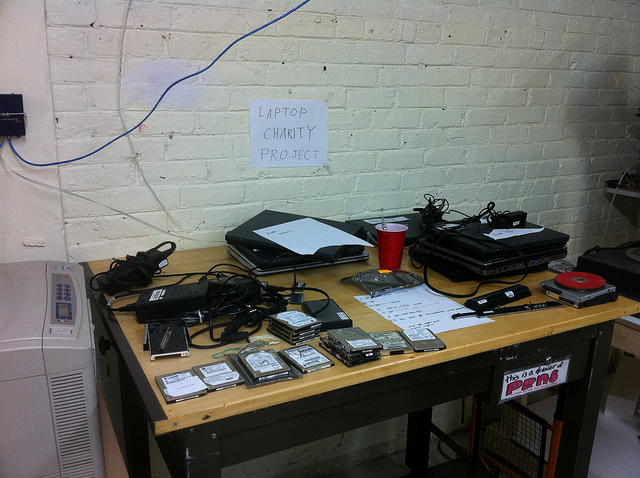<image>What logo is on the cup? I don't know what logo is on the cup. It can be 'solo' or none. What kind of pictures are shown? I am not sure what kind of pictures are shown. It could be cell phones, compact disks or computers. What logo is on the cup? I don't know what logo is on the cup. It can be either 'solo' or 'no logo'. What kind of pictures are shown? I don't know what kind of pictures are shown. It can be seen none, cell phones, compact disks, words, color, regular, or computers. 